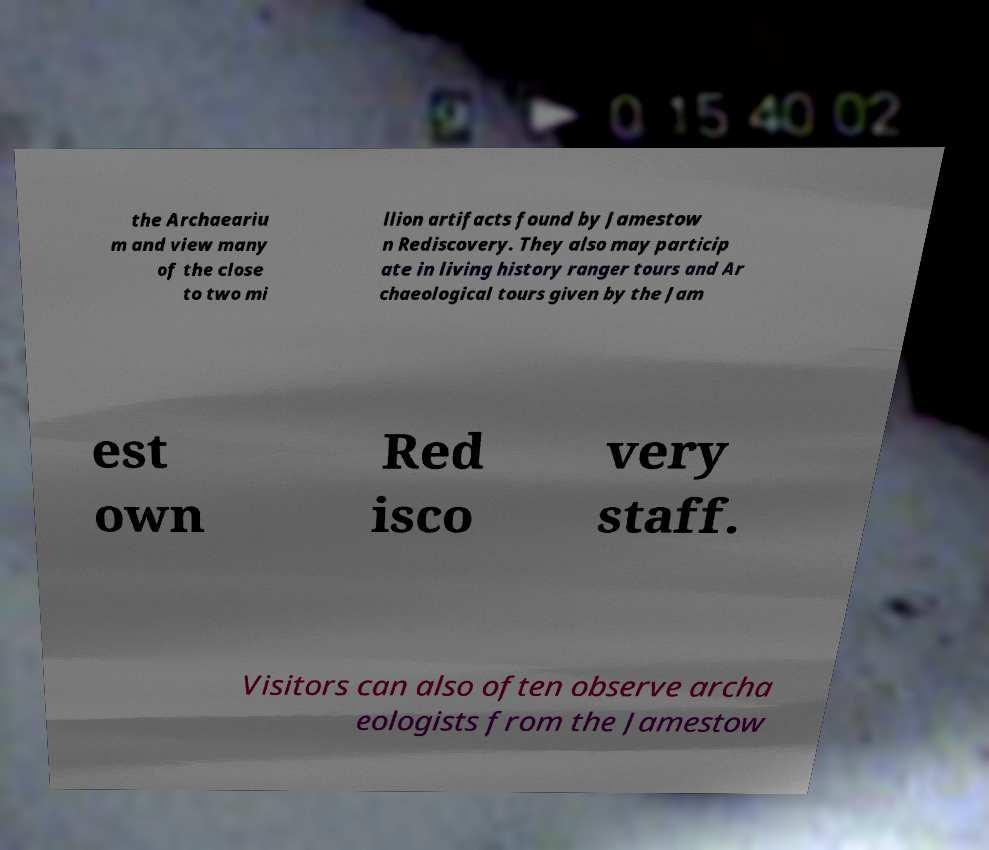I need the written content from this picture converted into text. Can you do that? the Archaeariu m and view many of the close to two mi llion artifacts found by Jamestow n Rediscovery. They also may particip ate in living history ranger tours and Ar chaeological tours given by the Jam est own Red isco very staff. Visitors can also often observe archa eologists from the Jamestow 